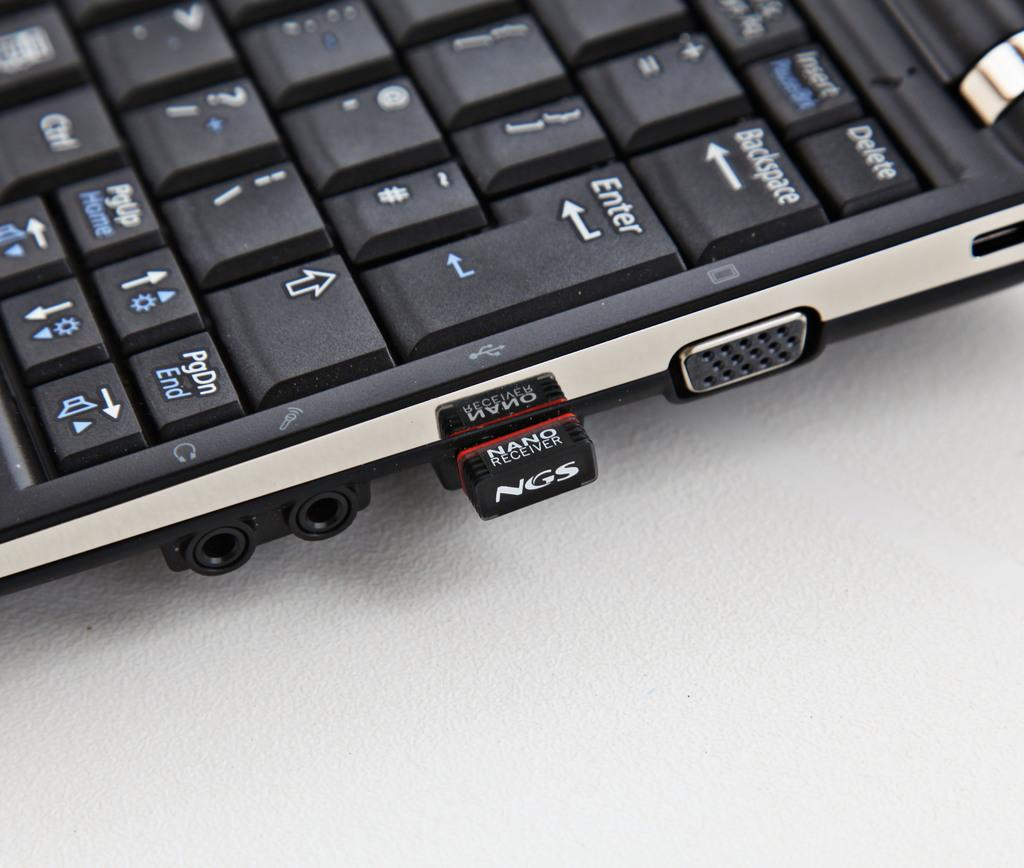<image>
Summarize the visual content of the image. A nano receiver is stuck in the the USB port on the laptop. 